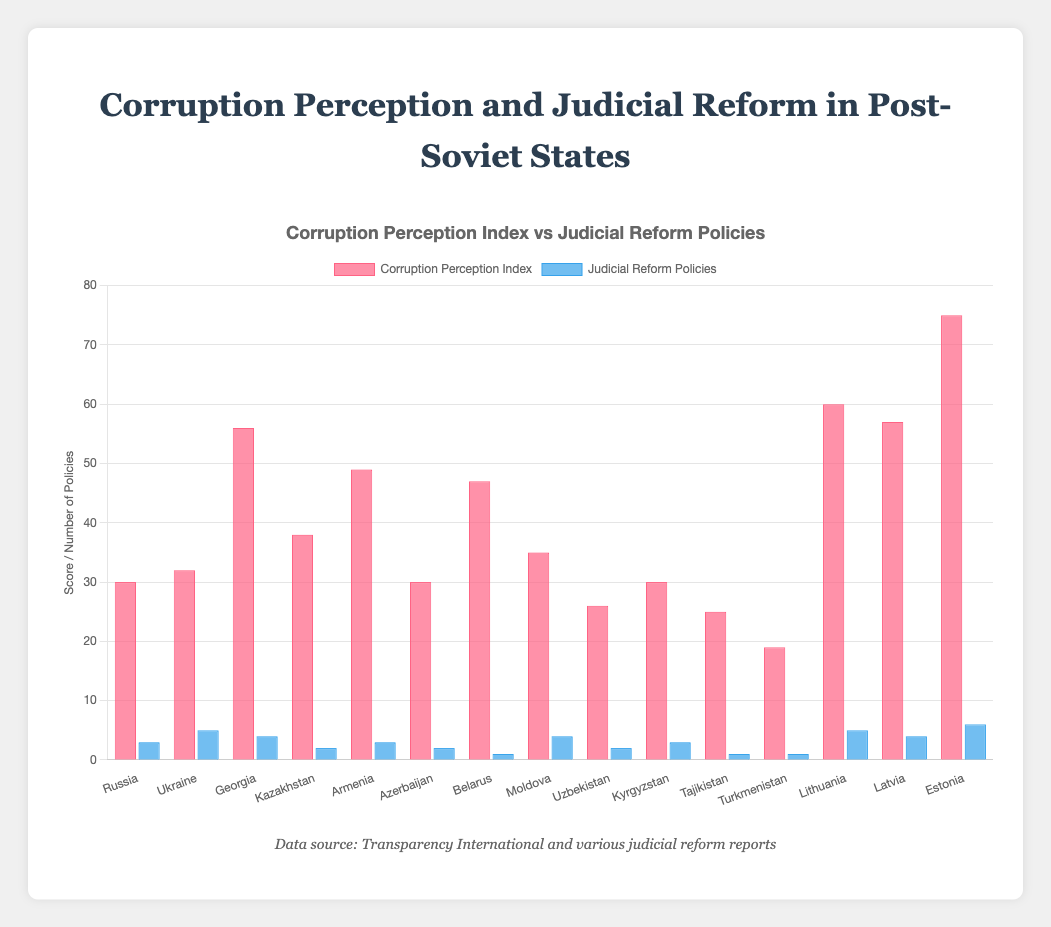Which country has the highest corruption perception index? By visually comparing the heights of the red bars, it is clear that Estonia has the highest corruption perception index at 75.
Answer: Estonia Which country has implemented the most judicial reform policies? By visually comparing the heights of the blue bars, it is clear that Estonia has implemented the most judicial reform policies with a total of 6 policies.
Answer: Estonia What is the total number of judicial reform policies implemented by Russia, Armenia, and Belarus combined? Russia has 3, Armenia has 3, and Belarus has 1 judicial reform policy. Adding them gives 3 + 3 + 1 = 7.
Answer: 7 Which post-Soviet country with a corruption perception index above 50 has the fewest judicial reform policies? The countries with a corruption perception index above 50 are Georgia (56), Lithuania (60), Latvia (57), and Estonia (75). Among these, Georgia and Latvia have the fewest judicial reform policies, with 4 each.
Answer: Georgia, Latvia What is the difference in the corruption perception index between the country with the highest index and the country with the lowest index? Estonia has the highest corruption perception index at 75, and Turkmenistan has the lowest at 19. The difference is 75 - 19 = 56.
Answer: 56 Which countries have a corruption perception index of 30, and how many judicial reform policies have these countries implemented? Russia, Azerbaijan, and Kyrgyzstan all have a corruption perception index of 30. They implemented 3, 2, and 3 judicial reform policies, respectively.
Answer: Russia: 3, Azerbaijan: 2, Kyrgyzstan: 3 How much higher is Lithuania's corruption perception index compared to Ukraine's? Lithuania has a corruption perception index of 60, and Ukraine has an index of 32. The difference is 60 - 32 = 28.
Answer: 28 Are there any countries with a corruption perception index below 30 that have implemented more than 2 judicial reform policies? The countries with a corruption perception index below 30 are Uzbekistan (26), Tajikistan (25), and Turkmenistan (19). None of these countries have implemented more than 2 judicial reform policies.
Answer: No 